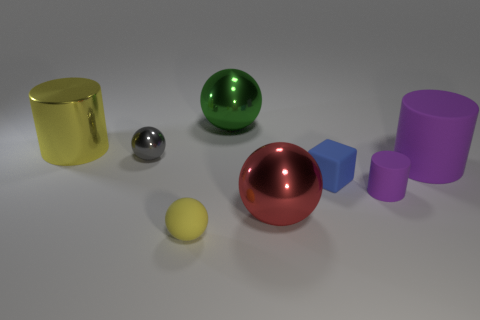Subtract 1 spheres. How many spheres are left? 3 Add 2 yellow metal cylinders. How many objects exist? 10 Subtract all cubes. How many objects are left? 7 Add 1 large gray metal cylinders. How many large gray metal cylinders exist? 1 Subtract 0 blue cylinders. How many objects are left? 8 Subtract all cyan balls. Subtract all small purple cylinders. How many objects are left? 7 Add 6 yellow matte things. How many yellow matte things are left? 7 